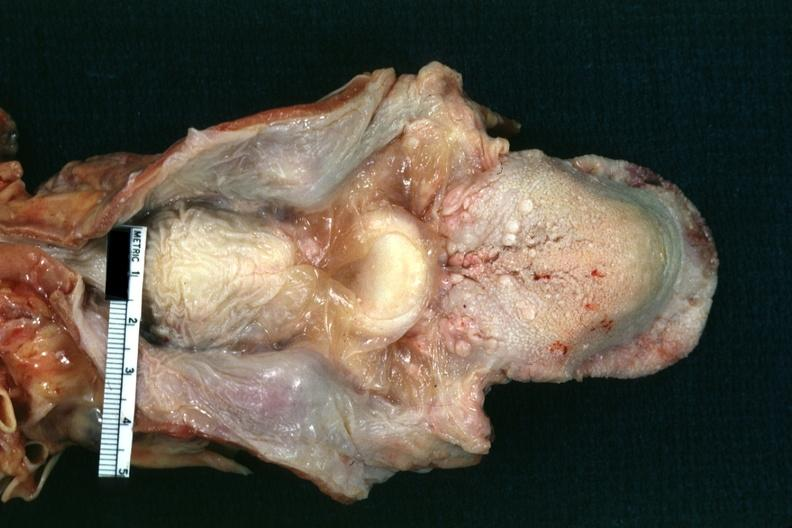s hypopharyngeal edema present?
Answer the question using a single word or phrase. Yes 